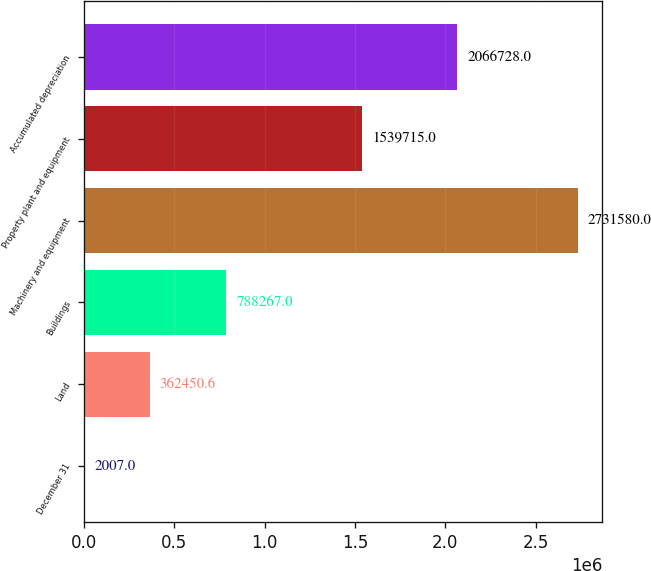Convert chart to OTSL. <chart><loc_0><loc_0><loc_500><loc_500><bar_chart><fcel>December 31<fcel>Land<fcel>Buildings<fcel>Machinery and equipment<fcel>Property plant and equipment<fcel>Accumulated depreciation<nl><fcel>2007<fcel>362451<fcel>788267<fcel>2.73158e+06<fcel>1.53972e+06<fcel>2.06673e+06<nl></chart> 